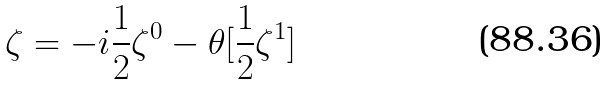<formula> <loc_0><loc_0><loc_500><loc_500>\zeta = - i \frac { 1 } { 2 } \zeta ^ { 0 } - \theta [ \frac { 1 } { 2 } \zeta ^ { 1 } ]</formula> 